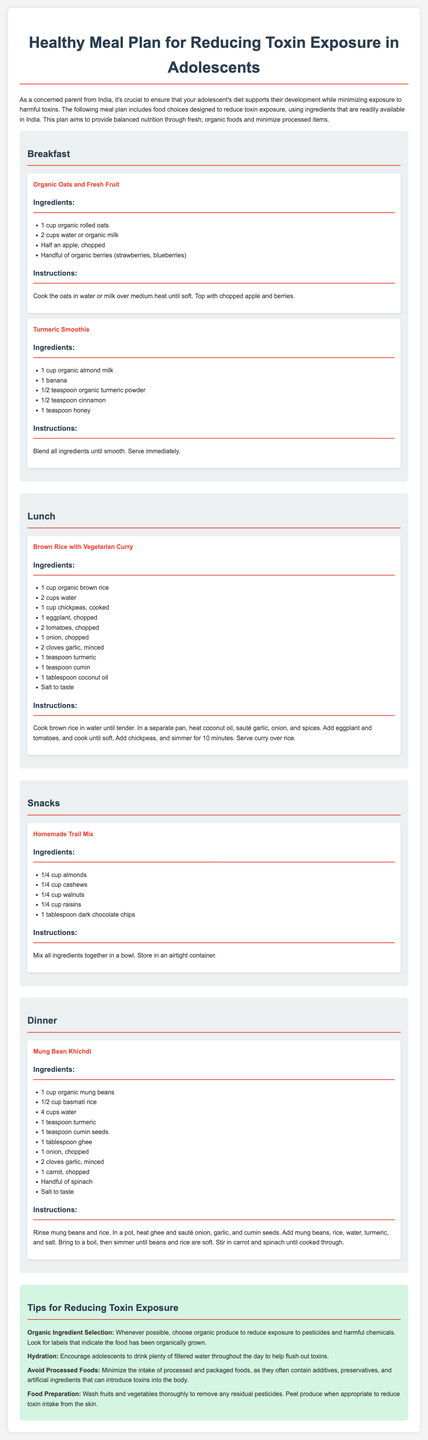what is the title of the document? The title of the document is mentioned in the header, highlighting the focus on meal planning for adolescents.
Answer: Healthy Meal Plan for Reducing Toxin Exposure in Adolescents how many meals are detailed in the meal plan? The document sections include Breakfast, Lunch, Snacks, and Dinner, totaling four meals outlined.
Answer: four what is one ingredient in the Organic Oats and Fresh Fruit? The ingredients list includes several items, one of which is specifically mentioned.
Answer: organic rolled oats which meal includes a smoothie? The meal that includes a smoothie is explicitly stated, showing its category in the plan.
Answer: Breakfast what type of rice is used in the Mung Bean Khichdi? The document clearly describes the type of rice used in this particular recipe.
Answer: basmati rice what is a tip for reducing toxin exposure? Tips listed provide specific recommendations around food consumption and preparation methods.
Answer: Choose organic produce In the Homemade Trail Mix, how much of each nut is included? The document quantifies the ingredients specified for the trail mix, focusing on the nut amounts.
Answer: 1/4 cup each what is the cooking method for the Brown Rice with Vegetarian Curry? The instructions for this meal indicate the method utilized, providing clarity on the preparation process.
Answer: sauté and simmer how many cups of water are used in the Brown Rice with Vegetarian Curry? The ingredients section explicitly states the amount of water needed for the preparation.
Answer: 2 cups 